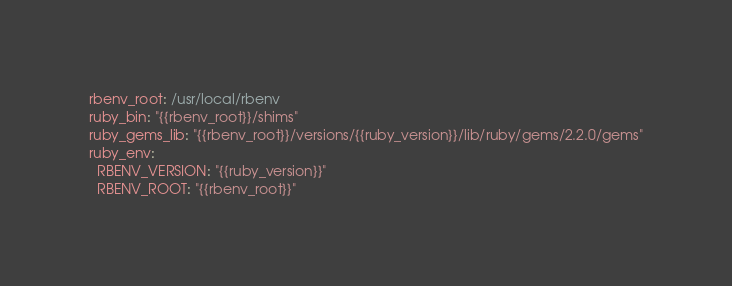Convert code to text. <code><loc_0><loc_0><loc_500><loc_500><_YAML_>rbenv_root: /usr/local/rbenv
ruby_bin: "{{rbenv_root}}/shims"
ruby_gems_lib: "{{rbenv_root}}/versions/{{ruby_version}}/lib/ruby/gems/2.2.0/gems"
ruby_env:
  RBENV_VERSION: "{{ruby_version}}"
  RBENV_ROOT: "{{rbenv_root}}"
</code> 